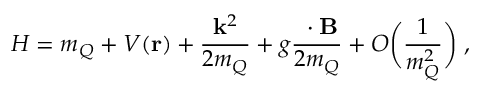<formula> <loc_0><loc_0><loc_500><loc_500>H = m _ { Q } + V ( { r } ) + \frac { { k } ^ { 2 } } { 2 m _ { Q } } + g \frac { { \sigma } \cdot { B } } { 2 m _ { Q } } + O \left ( \frac { 1 } { m _ { Q } ^ { 2 } } \right ) \, ,</formula> 